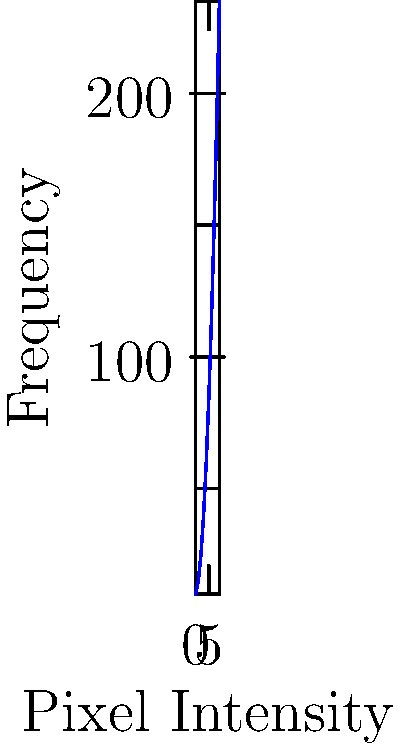Given the histogram of pixel intensities for a chest X-ray image shown above, calculate the signal-to-noise ratio (SNR) if the signal is represented by the peak at intensity 4 and the noise by the peak at intensity 1. Use the formula: $SNR = 20 \log_{10}(\frac{Signal}{Noise})$ dB. Round your answer to the nearest whole number. To calculate the signal-to-noise ratio (SNR), we'll follow these steps:

1. Identify the signal and noise values from the histogram:
   Signal (at intensity 4) = 60
   Noise (at intensity 1) = 15

2. Apply the SNR formula:
   $SNR = 20 \log_{10}(\frac{Signal}{Noise})$ dB

3. Substitute the values:
   $SNR = 20 \log_{10}(\frac{60}{15})$ dB

4. Calculate the ratio inside the logarithm:
   $SNR = 20 \log_{10}(4)$ dB

5. Calculate the logarithm:
   $SNR = 20 \times 0.6020599913$ dB

6. Multiply:
   $SNR = 12.04119983$ dB

7. Round to the nearest whole number:
   $SNR \approx 12$ dB

Therefore, the signal-to-noise ratio for this chest X-ray image is approximately 12 dB.
Answer: 12 dB 